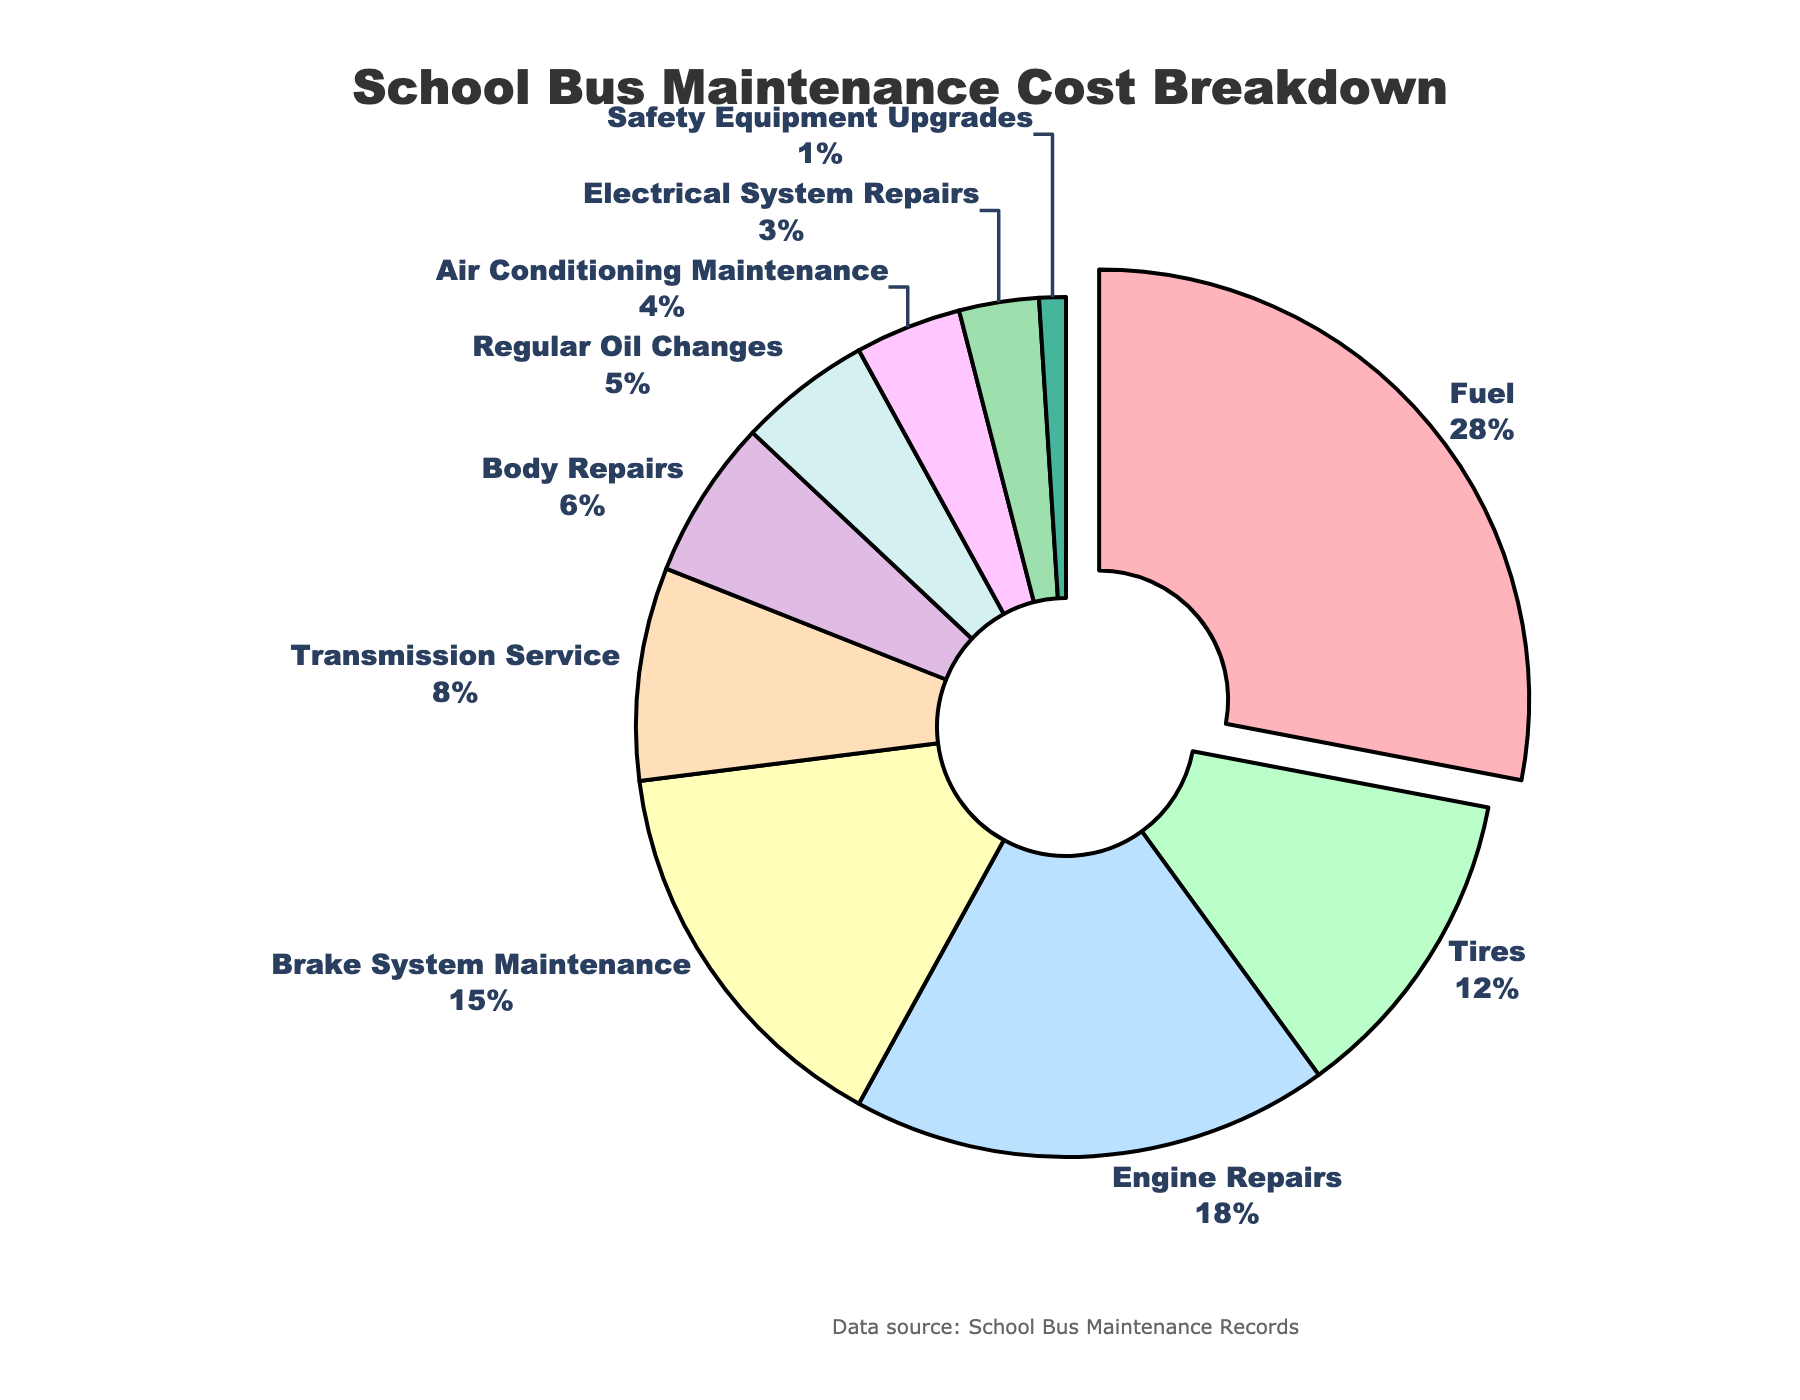What category has the largest percentage of school bus maintenance costs? The pie chart shows that the category with the largest percentage is slightly pulled out from the pie chart. The category pulled out the most and having the largest percentage is Fuel.
Answer: Fuel Which category contributes more to the maintenance costs: Tires or Brake System Maintenance? We look at the pie chart and find the two categories. Tires contribute 12%, while Brake System Maintenance contributes 15%. Therefore, Brake System Maintenance has a higher contribution.
Answer: Brake System Maintenance What is the combined percentage of Engine Repairs and Transmission Service? Engine Repairs have a percentage of 18%, and Transmission Service has 8%. Summing them up gives 18% + 8% = 26%.
Answer: 26% How does the percentage for Regular Oil Changes compare to Air Conditioning Maintenance? We look at the visual slices for Regular Oil Changes and Air Conditioning Maintenance. Regular Oil Changes contribute 5%, while Air Conditioning Maintenance contributes 4%. Therefore, Regular Oil Changes have a higher percentage.
Answer: Regular Oil Changes What percentage of the school bus maintenance cost is used for categories related to repairs (Engine Repairs, Body Repairs, and Electrical System Repairs)? Engine Repairs contribute 18%, Body Repairs contribute 6%, and Electrical System Repairs contribute 3%. Adding these percentages together gives 18% + 6% + 3% = 27%.
Answer: 27% What is the smallest category in the pie chart? The pie chart visually shows the smallest slice which corresponds to Safety Equipment Upgrades. This category has the smallest percentage at 1%.
Answer: Safety Equipment Upgrades Compare the combined percentage of Tires and Body Repairs to the percentage of Fuel. Which is greater? Tires contribute 12%, and Body Repairs contribute 6%. Adding these together gives 12% + 6% = 18%. Fuel contributes 28%, which is greater than the combined total of Tires and Body Repairs.
Answer: Fuel What is the difference in percentage between Brake System Maintenance and Transmission Service? Brake System Maintenance contributes 15%, and Transmission Service contributes 8%. The difference is 15% - 8% = 7%.
Answer: 7% What percentage of the school bus maintenance cost is related to the cooling system (Air Conditioning Maintenance)? The pie chart directly shows the percentage for Air Conditioning Maintenance which is 4%.
Answer: 4% Which categories together contribute exactly half of the total maintenance cost (50%)? Summing categories to find the combination that equals 50%:
Fuel (28%) + Engine Repairs (18%) + Transmission Service (4%) = 28% + 18% + 4% = 50%. Therefore, Fuel and Engine Repairs together make up half of the total maintenance cost.
Answer: Fuel, Engine Repairs 